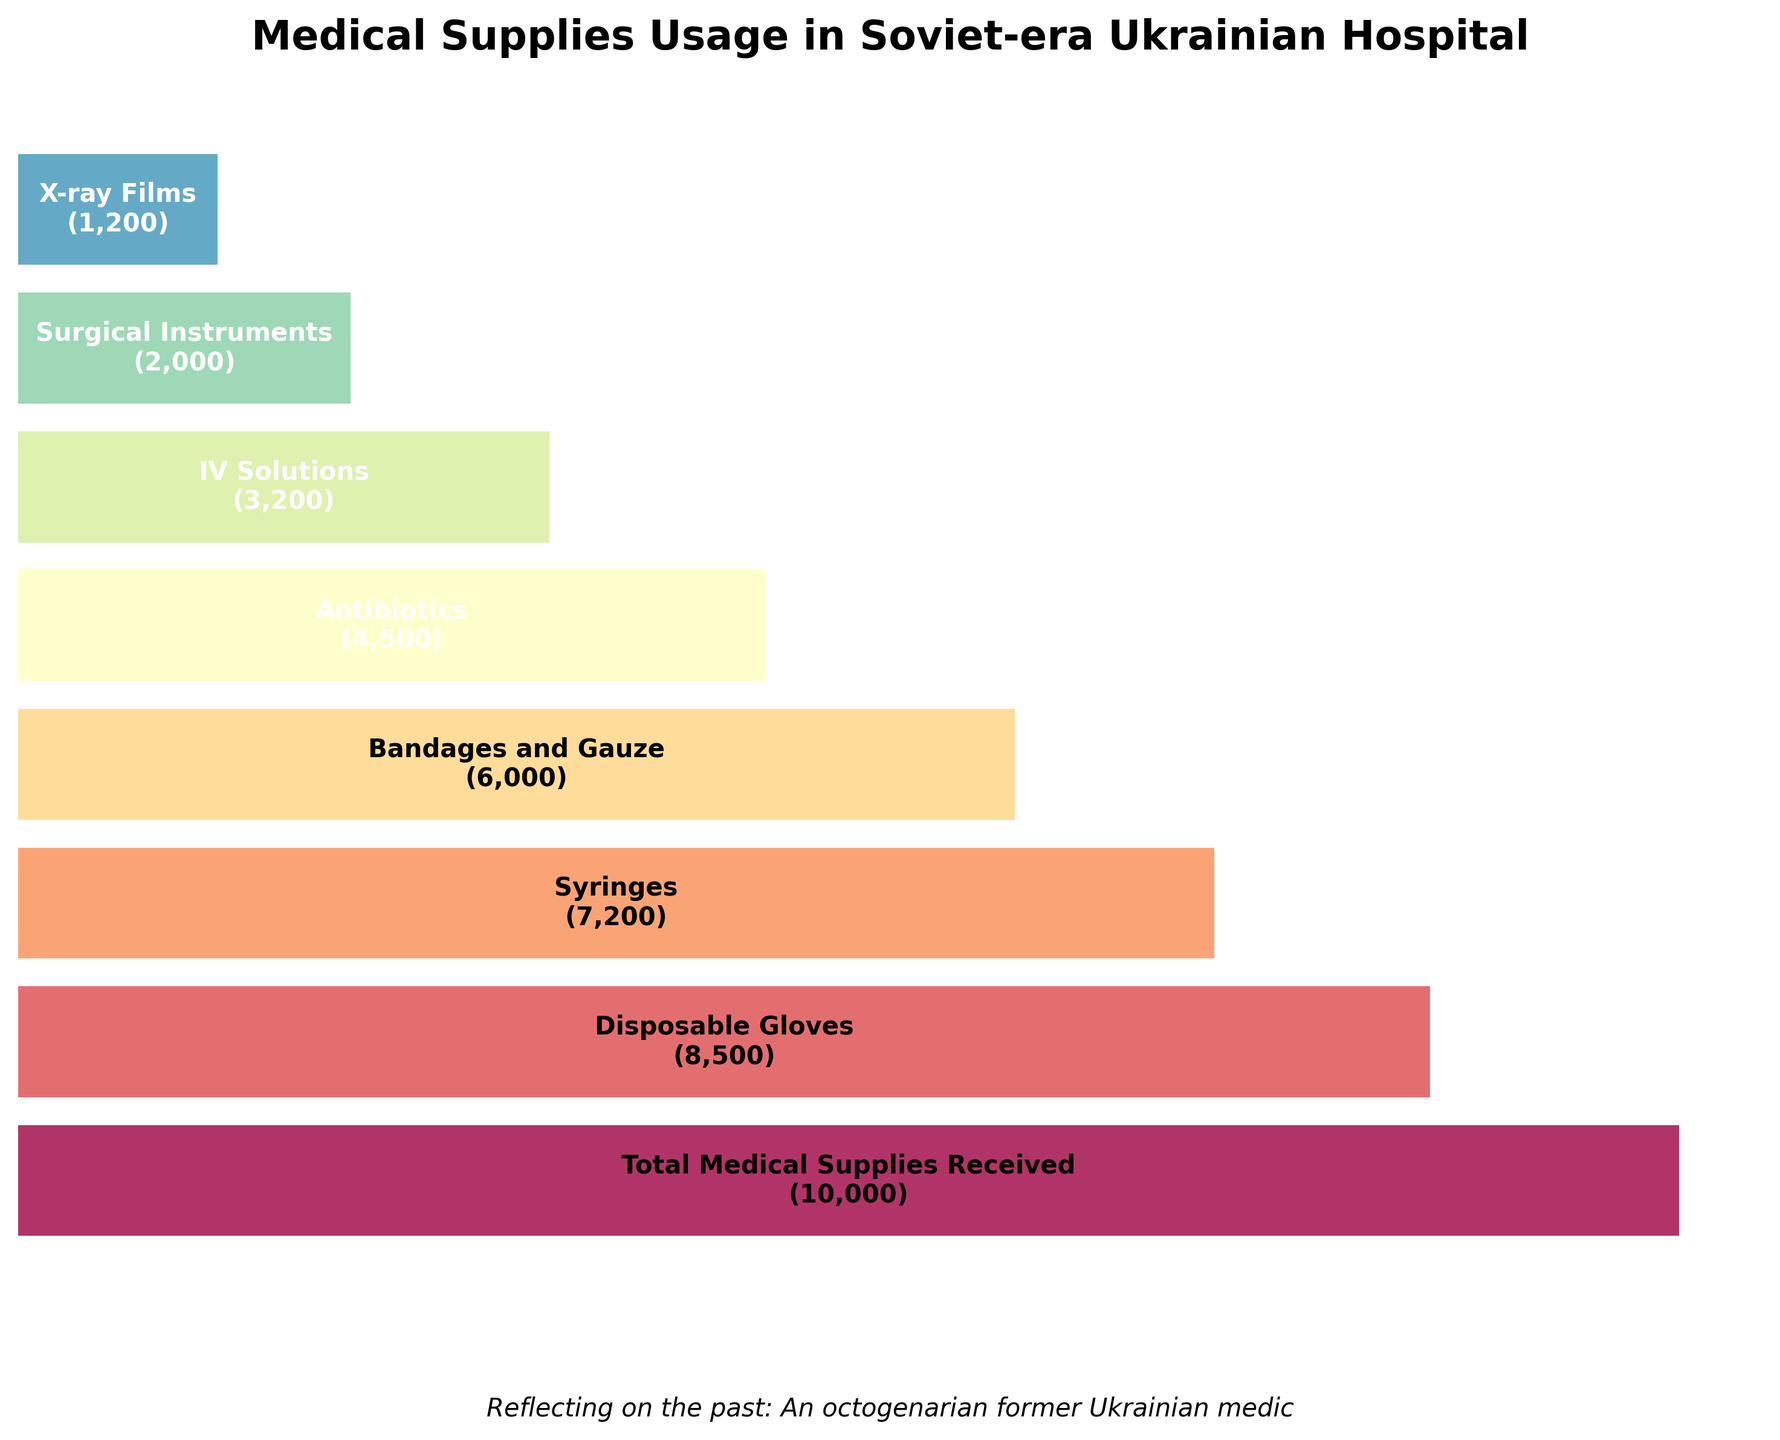What is the title of the funnel chart? The title of the chart is usually placed at the top, and it describes what the chart is about. In this case, it says "Medical Supplies Usage in Soviet-era Ukrainian Hospital."
Answer: Medical Supplies Usage in Soviet-era Ukrainian Hospital How many categories of medical supplies are depicted in the chart? By counting the different categories on the Y-axis of the funnel chart, we can determine the number of distinct categories of medical supplies shown.
Answer: 8 Which category has the highest quantity of usage? By observing the length of bars in the funnel chart, we find that the one at the top with "Total Medical Supplies Received" is the longest and thus has the highest quantity.
Answer: Total Medical Supplies Received What is the quantity of Disposable Gloves used? We look at the bar labeled "Disposable Gloves" and note the number shown within the bar.
Answer: 8500 Which category has the lowest quantity of usage? By examining the shortest bar at the bottom of the funnel chart, we find that "X-ray Films" has the smallest quantity.
Answer: X-ray Films How much fewer Bandages and Gauze were used compared to Disposable Gloves? We subtract the quantity of Bandages and Gauze (6000) from the quantity of Disposable Gloves (8500). The difference is 8500 - 6000.
Answer: 2500 What percentage of the total medical supplies received were Surgical Instruments? First, identify the total (10000) and the quantity for Surgical Instruments (2000). The percentage is calculated by (2000 / 10000) * 100.
Answer: 20% Between IV Solutions and Antibiotics, which category has a greater quantity of usage and by how much? IV Solutions have 3200 and Antibiotics have 4500 in quantity. We subtract the smaller from the larger: 4500 - 3200.
Answer: Antibiotics, 1300 more What is the cumulative total of IV Solutions, Surgical Instruments, and X-ray Films? Add the quantities of IV Solutions (3200), Surgical Instruments (2000), and X-ray Films (1200). The cumulative total is 3200 + 2000 + 1200.
Answer: 6400 Which supply category comes fifth in the decreasing order of usage quantities? By ordering the categories from highest to lowest quantities seen from the funnel chart, the fifth position is held by "Antibiotics."
Answer: Antibiotics 